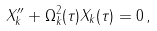Convert formula to latex. <formula><loc_0><loc_0><loc_500><loc_500>X _ { k } ^ { \prime \prime } + \Omega _ { k } ^ { 2 } ( \tau ) X _ { k } ( \tau ) = 0 \, ,</formula> 